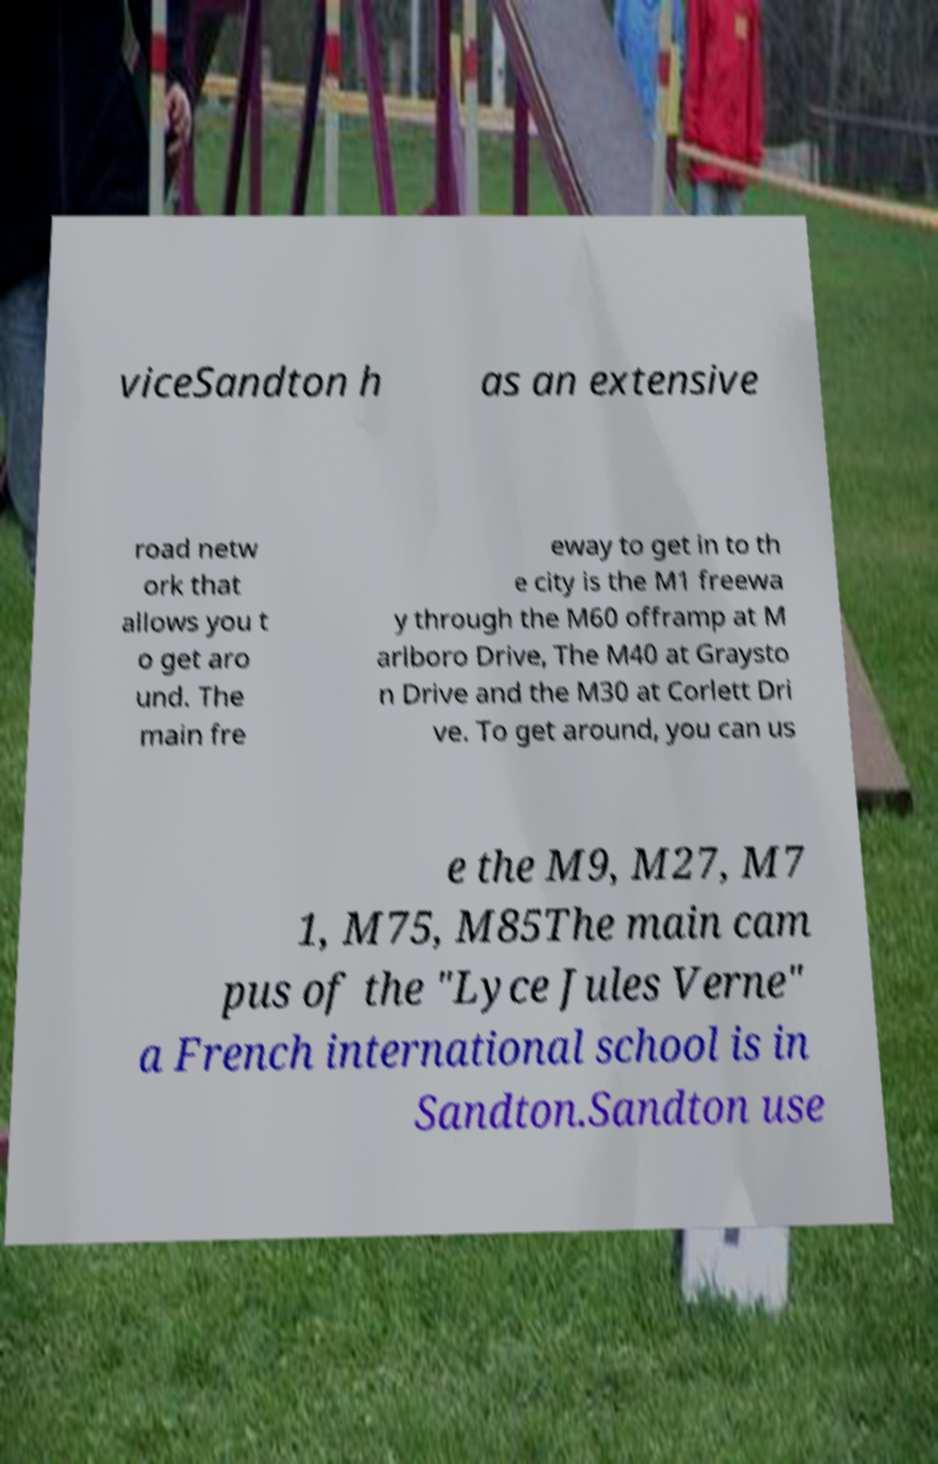Can you read and provide the text displayed in the image?This photo seems to have some interesting text. Can you extract and type it out for me? viceSandton h as an extensive road netw ork that allows you t o get aro und. The main fre eway to get in to th e city is the M1 freewa y through the M60 offramp at M arlboro Drive, The M40 at Graysto n Drive and the M30 at Corlett Dri ve. To get around, you can us e the M9, M27, M7 1, M75, M85The main cam pus of the "Lyce Jules Verne" a French international school is in Sandton.Sandton use 